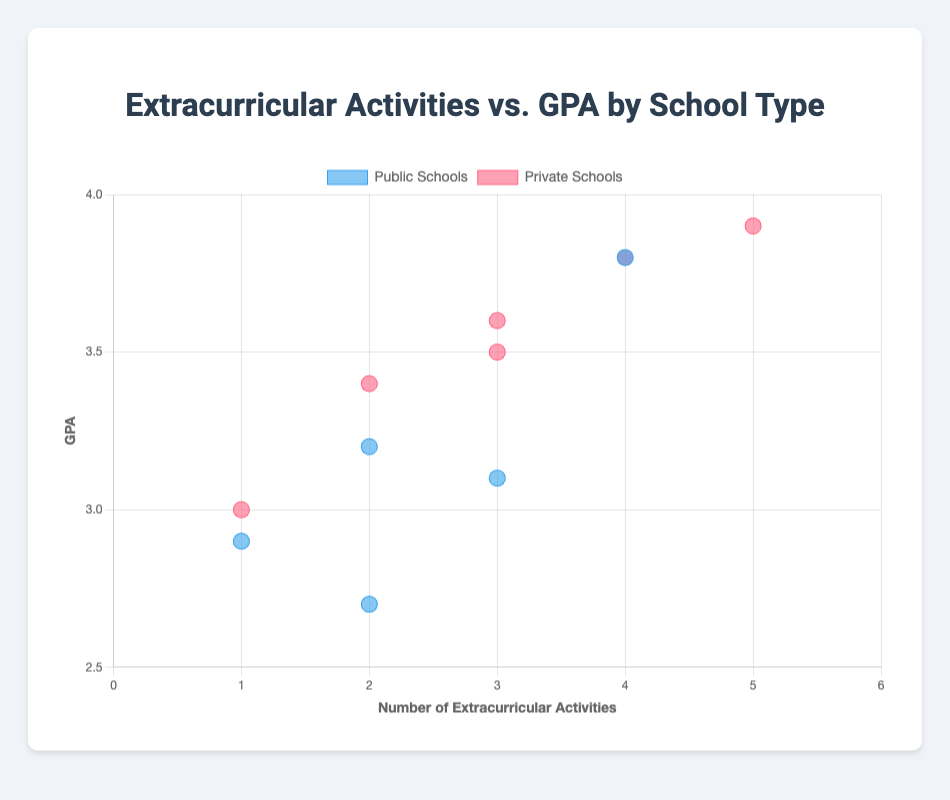What's the title of the figure? The title is directly displayed at the top of the figure in a larger and more distinct font.
Answer: Extracurricular Activities vs. GPA by School Type How many data points represent public schools? Count the number of points colored in blue, as the legend indicates that blue represents public schools.
Answer: 5 What is the maximum number of extracurricular activities engaged by private school students? Observe the furthest point to the right within the private school data points (red).
Answer: 5 Which school type generally has a higher average GPA? Compare and visually estimate the center of mass for both the blue (public) and red (private) data points on the Y-axis.
Answer: Private schools What is the approximate GPA range for students in public schools? Look at the lowest and highest GPA values among the blue data points on the Y-axis.
Answer: 2.7 to 3.8 Which school has the highest GPA among private school students with 4 extracurricular activities? Identify the red data points at x = 4 and find the highest point on the y-axis. The tooltip should show the school name.
Answer: Greenwood School Compare the number of extracurricular activities between the lowest GPA student and the highest GPA student in public schools. Find the blue data point with the lowest and highest y-values, and check their corresponding x-values.
Answer: Lowest GPA (2.7) has 2 activities; Highest GPA (3.8) has 4 activities Is there a stronger correlation between extracurricular activities and GPA in public or private schools? Observe the spread and trend of the data points for both public (blue) and private (red). Tighter clusters and more apparent trends indicate stronger correlation.
Answer: Private schools What's the difference in GPA between students with 1 extracurricular activity in public and private schools? Locate the points where x = 1 for both public (blue) and private (red), then find the y-values and calculate the difference.
Answer: 0.1 (3.0 - 2.9) 